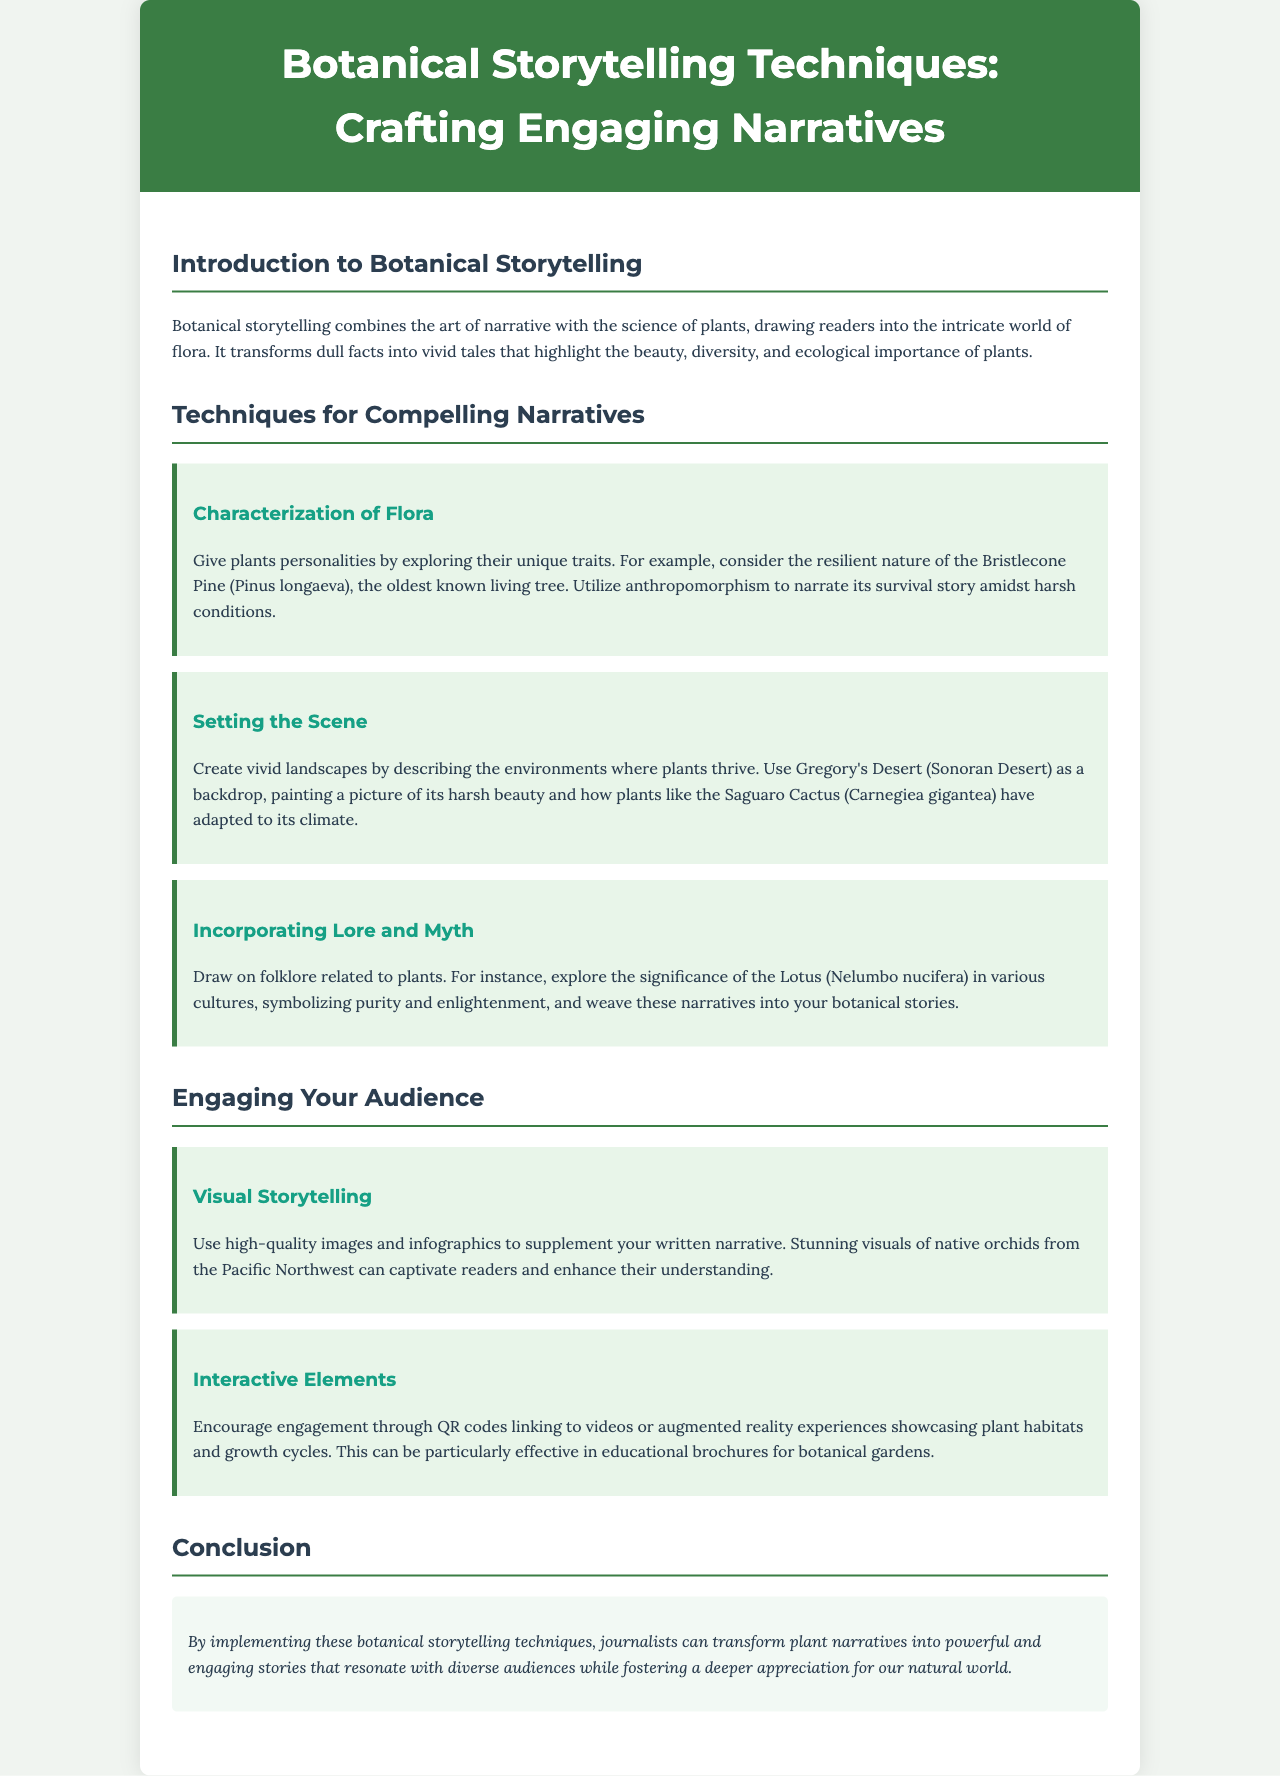what is the title of the brochure? The title is prominently displayed at the top of the document, indicating the focus of the content.
Answer: Botanical Storytelling Techniques: Crafting Engaging Narratives what is a technique for characterization of flora? The technique specifically mentioned explores anthropomorphism to give plants personalities, using a particular example.
Answer: Give plants personalities which plant is highlighted regarding setting the scene? This plant illustrates how a specific species adapts to its environment, enhancing the narrative of its resilience.
Answer: Saguaro Cactus what does the Lotus symbolize in different cultures? This aspect draws on the deeper meanings associated with a specific plant across various traditions.
Answer: Purity and enlightenment what visual element is suggested for enhancing narratives? This element is crucial for captivating readers by providing a deeper understanding of the content.
Answer: High-quality images how can QR codes be used in this context? The role of these elements is to enhance audience engagement, connecting them to multimedia experiences.
Answer: Linking to videos what is the main aim of botanical storytelling? This aim is summarized in the introduction, emphasizing the transformative power of narratives in relation to plants.
Answer: Engaging narratives which desert is mentioned as a setting in the document? Identifying this specific geographical area adds context to the storytelling regarding plant life.
Answer: Sonoran Desert what is the focus of the conclusion section? The conclusion reiterates the overarching theme of the brochure, encapsulating its message about storytelling techniques.
Answer: Transform plant narratives 